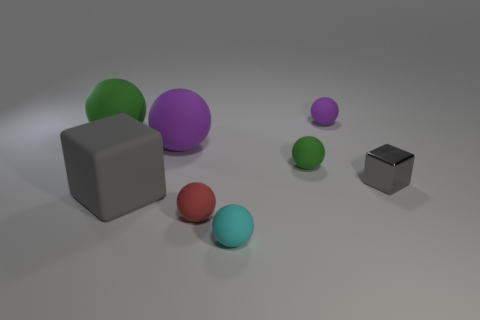What is the gray object that is left of the purple rubber ball right of the small cyan matte ball made of?
Ensure brevity in your answer.  Rubber. What shape is the thing that is the same color as the large block?
Offer a very short reply. Cube. Is there a big ball that has the same material as the large gray block?
Offer a terse response. Yes. Are the cyan sphere and the gray block that is on the left side of the shiny cube made of the same material?
Your answer should be compact. Yes. There is a metal object that is the same size as the red matte object; what color is it?
Your answer should be compact. Gray. What is the size of the object behind the large green rubber object on the left side of the small metallic thing?
Provide a succinct answer. Small. Is the color of the small metal thing the same as the big thing to the left of the large gray matte cube?
Offer a very short reply. No. Is the number of small red matte objects right of the small gray metal thing less than the number of small rubber spheres?
Offer a very short reply. Yes. What number of other things are the same size as the cyan rubber sphere?
Your response must be concise. 4. Do the small metal object that is in front of the large purple sphere and the small purple rubber object have the same shape?
Offer a very short reply. No. 